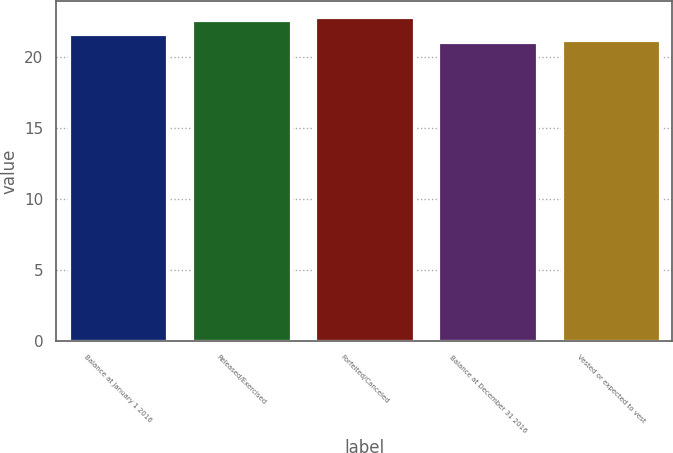<chart> <loc_0><loc_0><loc_500><loc_500><bar_chart><fcel>Balance at January 1 2016<fcel>Released/Exercised<fcel>Forfeited/Canceled<fcel>Balance at December 31 2016<fcel>Vested or expected to vest<nl><fcel>21.62<fcel>22.6<fcel>22.76<fcel>21.02<fcel>21.18<nl></chart> 